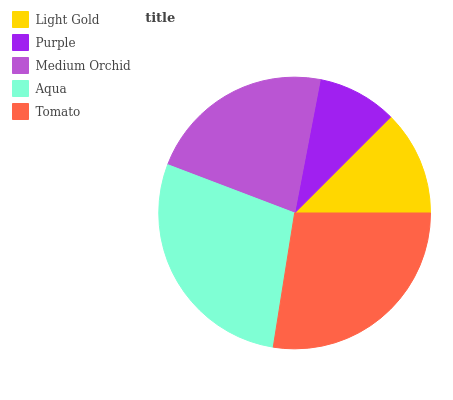Is Purple the minimum?
Answer yes or no. Yes. Is Aqua the maximum?
Answer yes or no. Yes. Is Medium Orchid the minimum?
Answer yes or no. No. Is Medium Orchid the maximum?
Answer yes or no. No. Is Medium Orchid greater than Purple?
Answer yes or no. Yes. Is Purple less than Medium Orchid?
Answer yes or no. Yes. Is Purple greater than Medium Orchid?
Answer yes or no. No. Is Medium Orchid less than Purple?
Answer yes or no. No. Is Medium Orchid the high median?
Answer yes or no. Yes. Is Medium Orchid the low median?
Answer yes or no. Yes. Is Aqua the high median?
Answer yes or no. No. Is Tomato the low median?
Answer yes or no. No. 